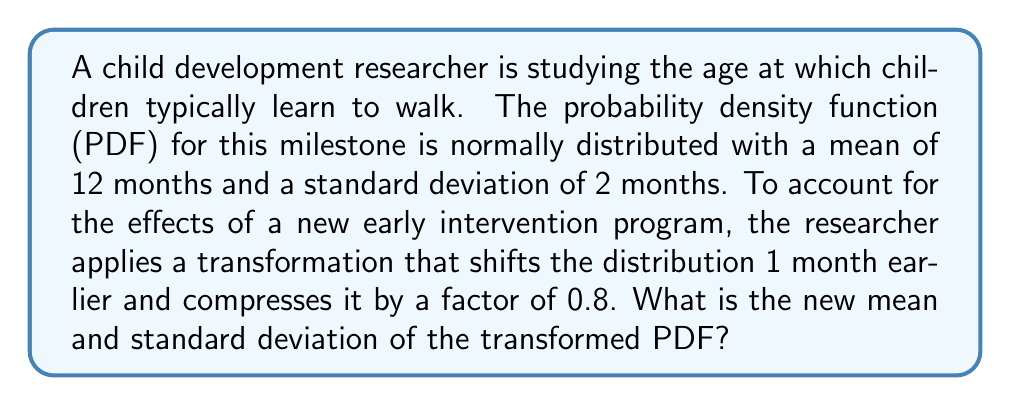Provide a solution to this math problem. Let's approach this step-by-step:

1) The original PDF is normally distributed with:
   $\mu = 12$ months
   $\sigma = 2$ months

2) The transformation involves two steps:
   a) Shifting the distribution 1 month earlier
   b) Compressing it by a factor of 0.8

3) For a linear transformation of the form $Y = aX + b$, where $X$ is the original random variable:
   - The new mean: $\mu_Y = a\mu_X + b$
   - The new standard deviation: $\sigma_Y = |a|\sigma_X$

4) In our case:
   $a = 0.8$ (compression factor)
   $b = -1$ (shift 1 month earlier)

5) Calculate the new mean:
   $\mu_Y = 0.8(12) + (-1) = 9.6 - 1 = 8.6$ months

6) Calculate the new standard deviation:
   $\sigma_Y = |0.8|(2) = 1.6$ months

Therefore, the transformed PDF has a mean of 8.6 months and a standard deviation of 1.6 months.
Answer: Mean: 8.6 months, Standard deviation: 1.6 months 